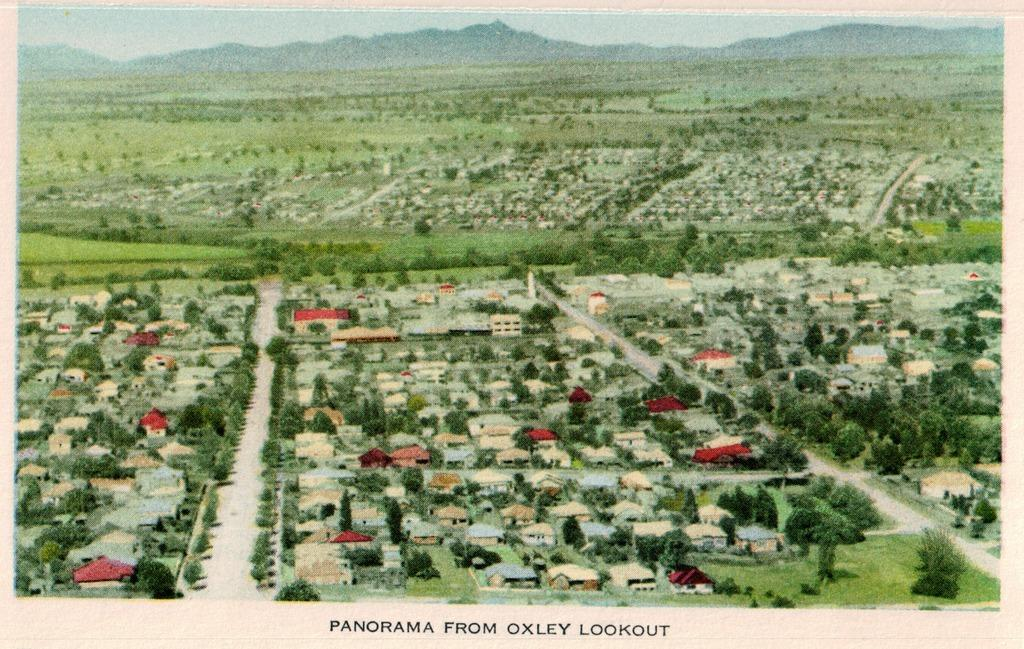What is the main subject of the image? The main subject of the image is a poster. What types of images are included on the poster? The poster contains images of houses, trees, and hills. Is there any text on the poster? Yes, there is text at the bottom of the image. How does the poster guide people through a forest in the image? The poster does not guide people through a forest in the image; it only contains images of houses, trees, and hills. 